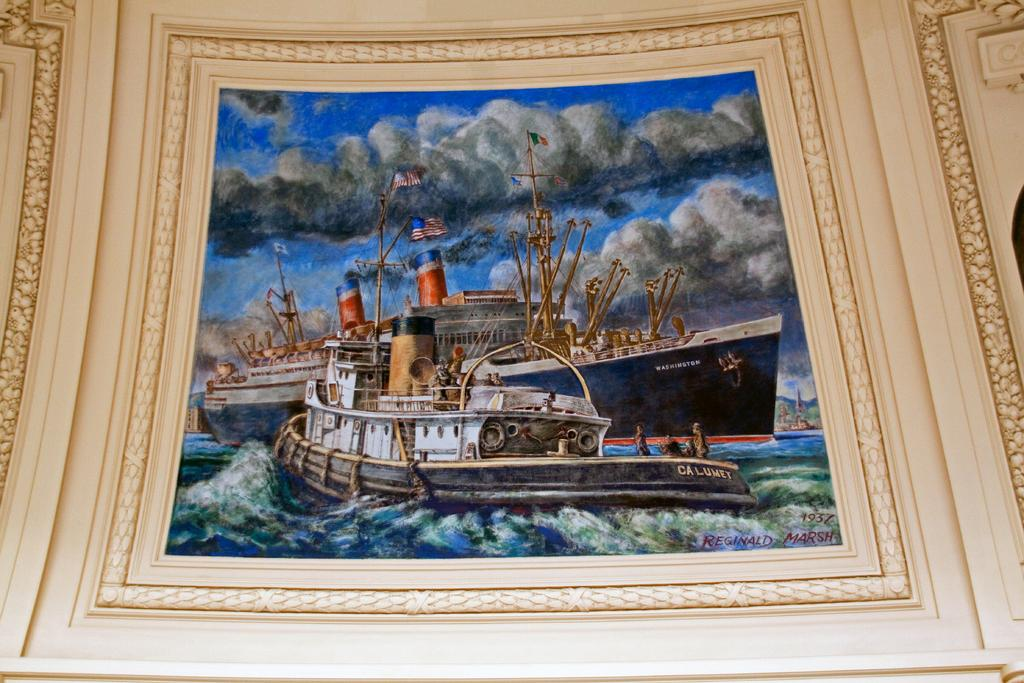What is hanging on the wall in the image? There is a frame on a wall in the image. What is depicted in the frame? The frame contains a picture of three ships. Where are the ships located in the picture? The ships are on the ocean. What can be seen in the background of the picture? There is a sky visible in the image, and it contains clouds. Who is responsible for the selection of the ships in the image? There is no information about a selection process or committee in the image, as it simply depicts a picture of three ships on the ocean. 